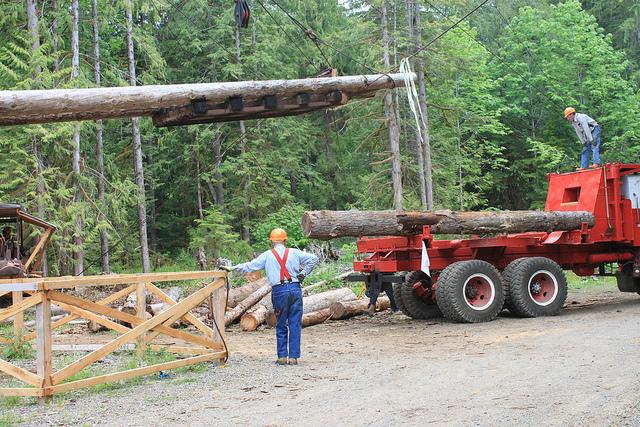Is this photo taken in the woods?
Give a very brief answer. Yes. What color are the suspenders worn by the person in the foreground?
Quick response, please. Red. Are the orange hats necessary?
Quick response, please. Yes. 